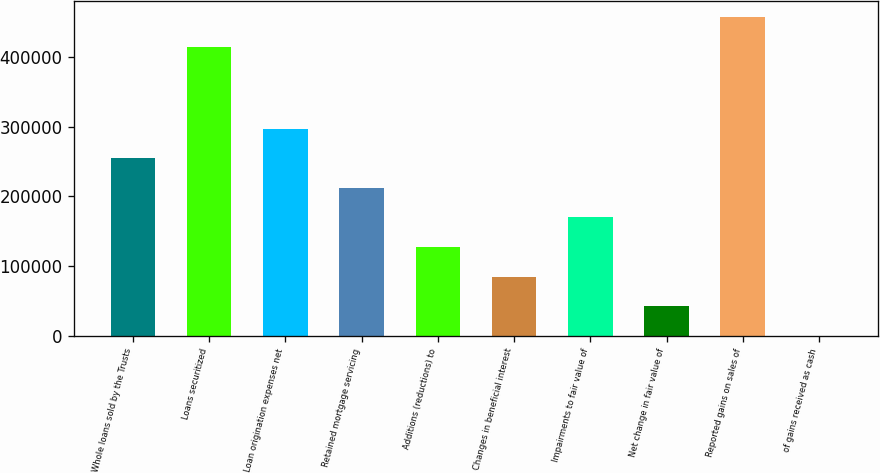Convert chart to OTSL. <chart><loc_0><loc_0><loc_500><loc_500><bar_chart><fcel>Whole loans sold by the Trusts<fcel>Loans securitized<fcel>Loan origination expenses net<fcel>Retained mortgage servicing<fcel>Additions (reductions) to<fcel>Changes in beneficial interest<fcel>Impairments to fair value of<fcel>Net change in fair value of<fcel>Reported gains on sales of<fcel>of gains received as cash<nl><fcel>254675<fcel>414844<fcel>297106<fcel>212244<fcel>127380<fcel>84949<fcel>169812<fcel>42517.5<fcel>457276<fcel>86<nl></chart> 